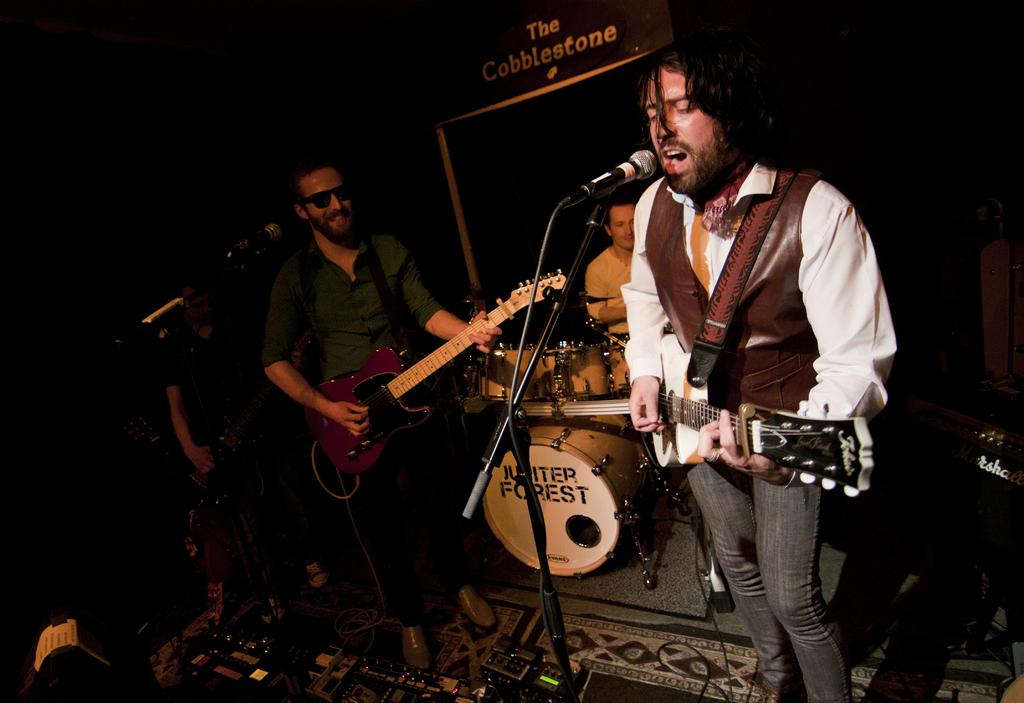What are the people in the image doing? The people in the image are holding guitars. Is there anyone else in the image besides the people holding guitars? Yes, there is a person is sitting in the image. What is the sitting person doing? The sitting person is playing a drum set. Are there any beggars visible in the image? There is no mention of a beggar in the image, so we cannot say if one is present or not. 